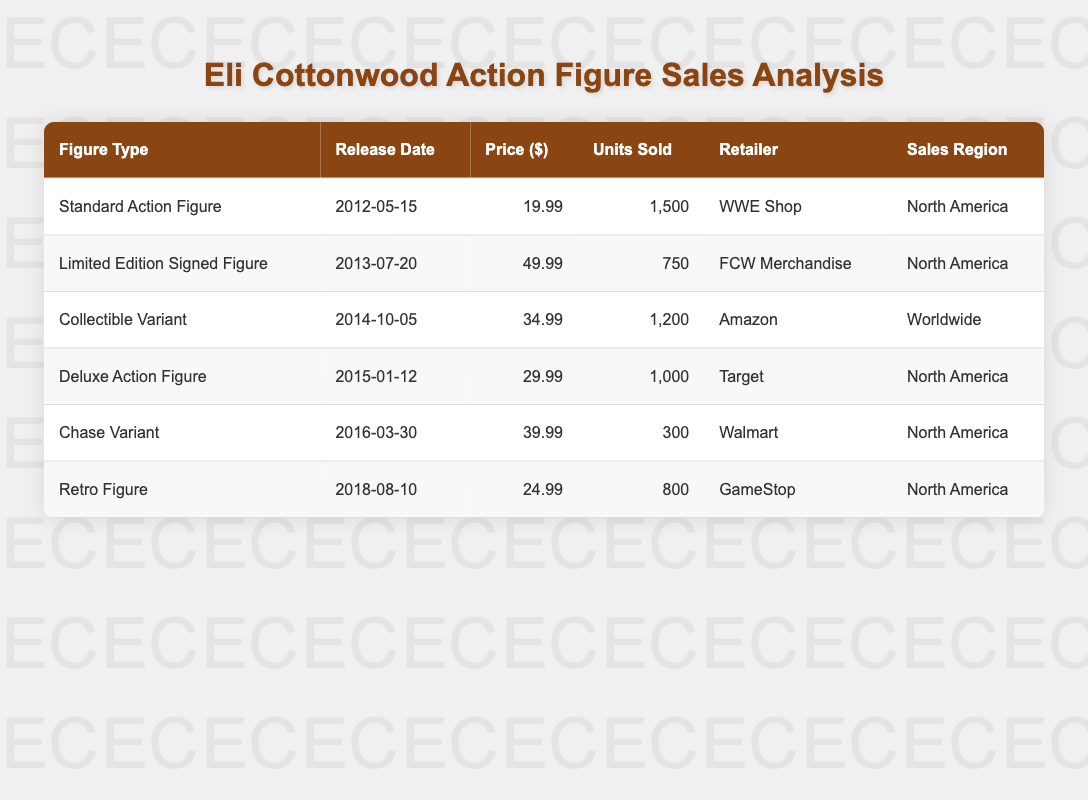What is the total number of units sold for all Eli Cottonwood action figures? To get the total units sold, we need to add up the Units Sold from each figure: 1500 (Standard Action Figure) + 750 (Limited Edition Signed Figure) + 1200 (Collectible Variant) + 1000 (Deluxe Action Figure) + 300 (Chase Variant) + 800 (Retro Figure) = 4550.
Answer: 4550 Which action figure had the highest sale price? By checking the Price column, the Limited Edition Signed Figure has the highest price at 49.99.
Answer: Limited Edition Signed Figure How many more units were sold of the Standard Action Figure compared to the Chase Variant? Subtract the Units Sold of the Chase Variant (300) from the Standard Action Figure (1500): 1500 - 300 = 1200.
Answer: 1200 Is the Collectible Variant sold in North America? Looking at the Sales Region for the Collectible Variant, it shows Worldwide, indicating that it is not only sold in North America.
Answer: No What is the average price of the action figures listed? The total price is calculated as follows: 19.99 + 49.99 + 34.99 + 29.99 + 39.99 + 24.99 = 199.94. There are 6 figures, so the average price is 199.94 / 6 ≈ 33.32.
Answer: 33.32 Which retailer sold the most units of Eli Cottonwood action figures? By examining Units Sold, WWE Shop sold 1500, FCW Merchandise sold 750, Amazon sold 1200, Target sold 1000, Walmart sold 300, and GameStop sold 800. WWE Shop has the highest total with 1500 units.
Answer: WWE Shop What percentage of the total units sold were from the Deluxe Action Figure? The Deluxe Action Figure sold 1000 units. To find the percentage: (1000 / 4550) * 100 ≈ 22.0%.
Answer: 22.0% Which figure had the earliest release date? By reviewing the Release Dates, the earliest date is for the Standard Action Figure on 2012-05-15.
Answer: Standard Action Figure 